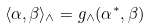Convert formula to latex. <formula><loc_0><loc_0><loc_500><loc_500>\langle \alpha , \beta \rangle _ { \wedge } = g _ { \wedge } ( \alpha ^ { * } , \beta )</formula> 